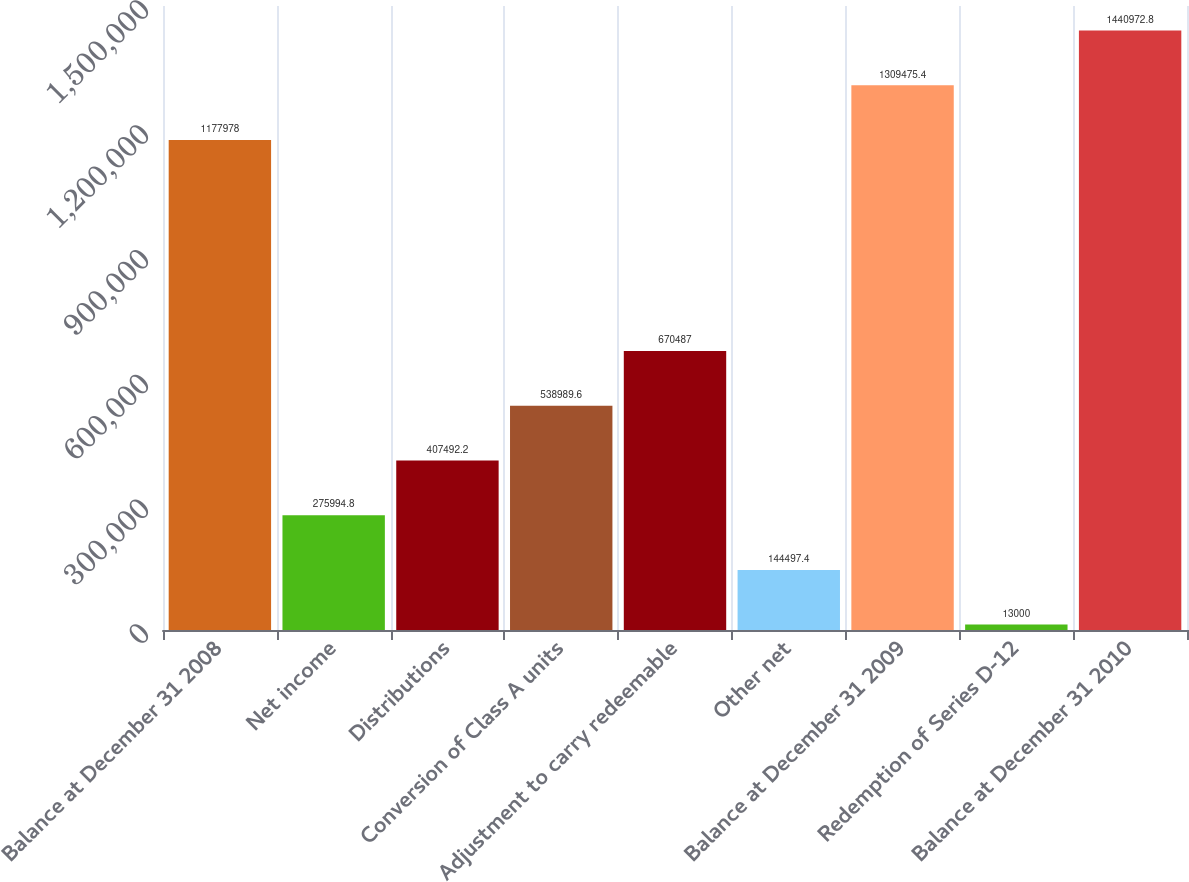<chart> <loc_0><loc_0><loc_500><loc_500><bar_chart><fcel>Balance at December 31 2008<fcel>Net income<fcel>Distributions<fcel>Conversion of Class A units<fcel>Adjustment to carry redeemable<fcel>Other net<fcel>Balance at December 31 2009<fcel>Redemption of Series D-12<fcel>Balance at December 31 2010<nl><fcel>1.17798e+06<fcel>275995<fcel>407492<fcel>538990<fcel>670487<fcel>144497<fcel>1.30948e+06<fcel>13000<fcel>1.44097e+06<nl></chart> 